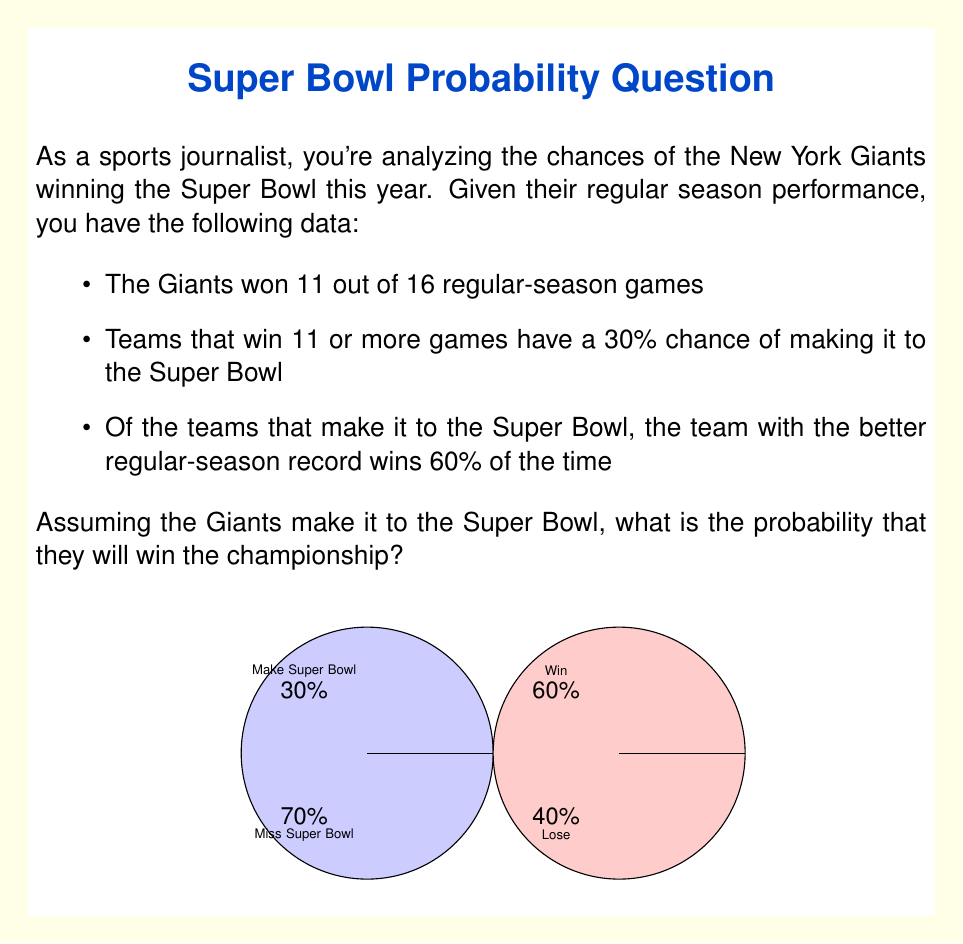Can you answer this question? Let's break this down step-by-step:

1) First, we need to understand what the question is asking. We're not calculating the overall probability of the Giants winning the Super Bowl, but rather their probability of winning IF they make it to the Super Bowl.

2) The information about the Giants winning 11 out of 16 regular-season games and having a 30% chance of making it to the Super Bowl is not directly relevant to this calculation, as we're assuming they've already made it to the Super Bowl.

3) The key information is: "Of the teams that make it to the Super Bowl, the team with the better regular-season record wins 60% of the time."

4) We can assume that if the Giants make it to the Super Bowl, they are likely to have one of the better regular-season records among all teams.

5) Therefore, the probability of the Giants winning the Super Bowl, given that they've made it there, is simply 60% or 0.60.

6) In probability notation, we can express this as:

   $$P(\text{Giants win} | \text{Giants in Super Bowl}) = 0.60$$

   This reads as "The probability that the Giants win, given that they are in the Super Bowl, is 0.60."
Answer: $0.60$ or $60\%$ 